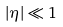<formula> <loc_0><loc_0><loc_500><loc_500>| \eta | \ll 1</formula> 